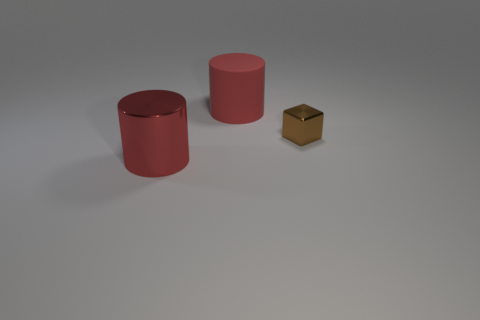What is the material of the cylinder that is the same color as the matte object?
Your answer should be compact. Metal. Does the big metallic cylinder have the same color as the large rubber cylinder?
Your answer should be very brief. Yes. Is there anything else that is the same size as the brown shiny cube?
Give a very brief answer. No. What is the material of the other object that is the same shape as the large matte object?
Offer a very short reply. Metal. There is another cylinder that is the same size as the red metallic cylinder; what is it made of?
Ensure brevity in your answer.  Rubber. Is the number of objects that are in front of the large red metallic thing less than the number of yellow balls?
Ensure brevity in your answer.  No. There is a brown metallic thing that is on the right side of the big red cylinder that is behind the large red shiny cylinder in front of the block; what shape is it?
Your response must be concise. Cube. There is a metal thing to the left of the red matte thing; what is its size?
Your response must be concise. Large. What shape is the other object that is the same size as the red matte object?
Your answer should be very brief. Cylinder. What number of objects are either cubes or objects that are to the left of the tiny metal cube?
Provide a short and direct response. 3. 